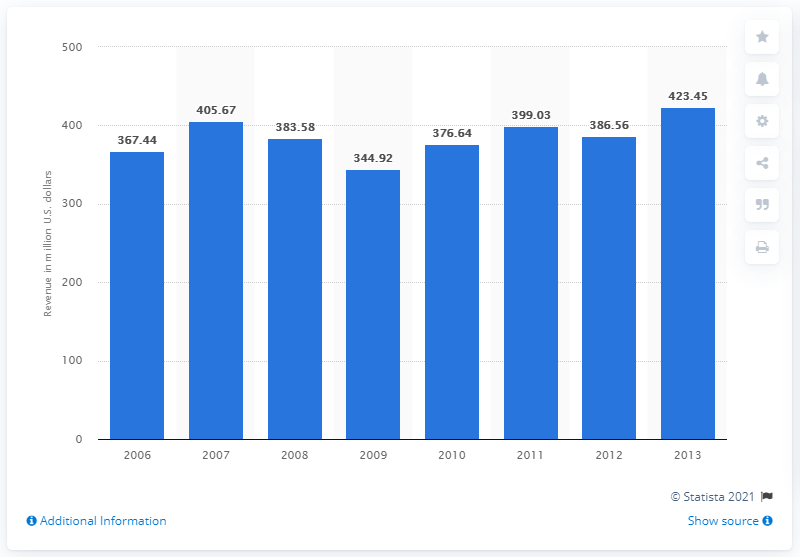Give some essential details in this illustration. In 2012, Cosmopolitan magazine generated approximately $386.56 million in advertising revenue. 